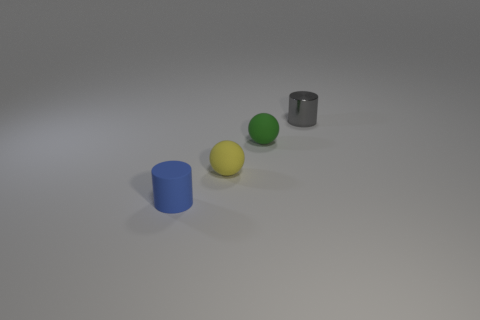Do the small gray object and the green thing have the same shape?
Give a very brief answer. No. Are there fewer green cylinders than cylinders?
Ensure brevity in your answer.  Yes. What shape is the rubber object to the right of the rubber ball that is in front of the small green matte object right of the yellow matte thing?
Make the answer very short. Sphere. There is a small cylinder that is the same material as the green sphere; what is its color?
Keep it short and to the point. Blue. The cylinder that is to the left of the tiny cylinder that is behind the cylinder that is to the left of the metal thing is what color?
Make the answer very short. Blue. How many balls are blue rubber things or small yellow rubber objects?
Your answer should be very brief. 1. The metal cylinder is what color?
Your response must be concise. Gray. What number of things are either green spheres or yellow things?
Provide a short and direct response. 2. There is a green object that is the same size as the blue rubber cylinder; what is it made of?
Your response must be concise. Rubber. What is the material of the small gray object?
Make the answer very short. Metal. 